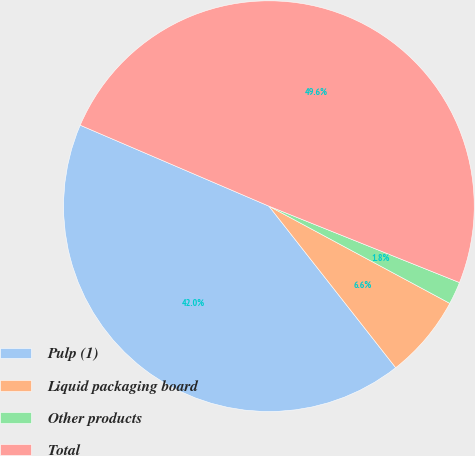<chart> <loc_0><loc_0><loc_500><loc_500><pie_chart><fcel>Pulp (1)<fcel>Liquid packaging board<fcel>Other products<fcel>Total<nl><fcel>42.04%<fcel>6.56%<fcel>1.78%<fcel>49.62%<nl></chart> 